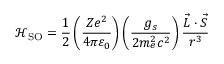<formula> <loc_0><loc_0><loc_500><loc_500>{ \mathcal { H } } _ { S O } = { \frac { 1 } { 2 } } \left ( { \frac { Z e ^ { 2 } } { 4 \pi \varepsilon _ { 0 } } } \right ) \left ( { \frac { g _ { s } } { 2 m _ { e } ^ { 2 } c ^ { 2 } } } \right ) { \frac { { \vec { L } } \cdot { \vec { S } } } { r ^ { 3 } } }</formula> 